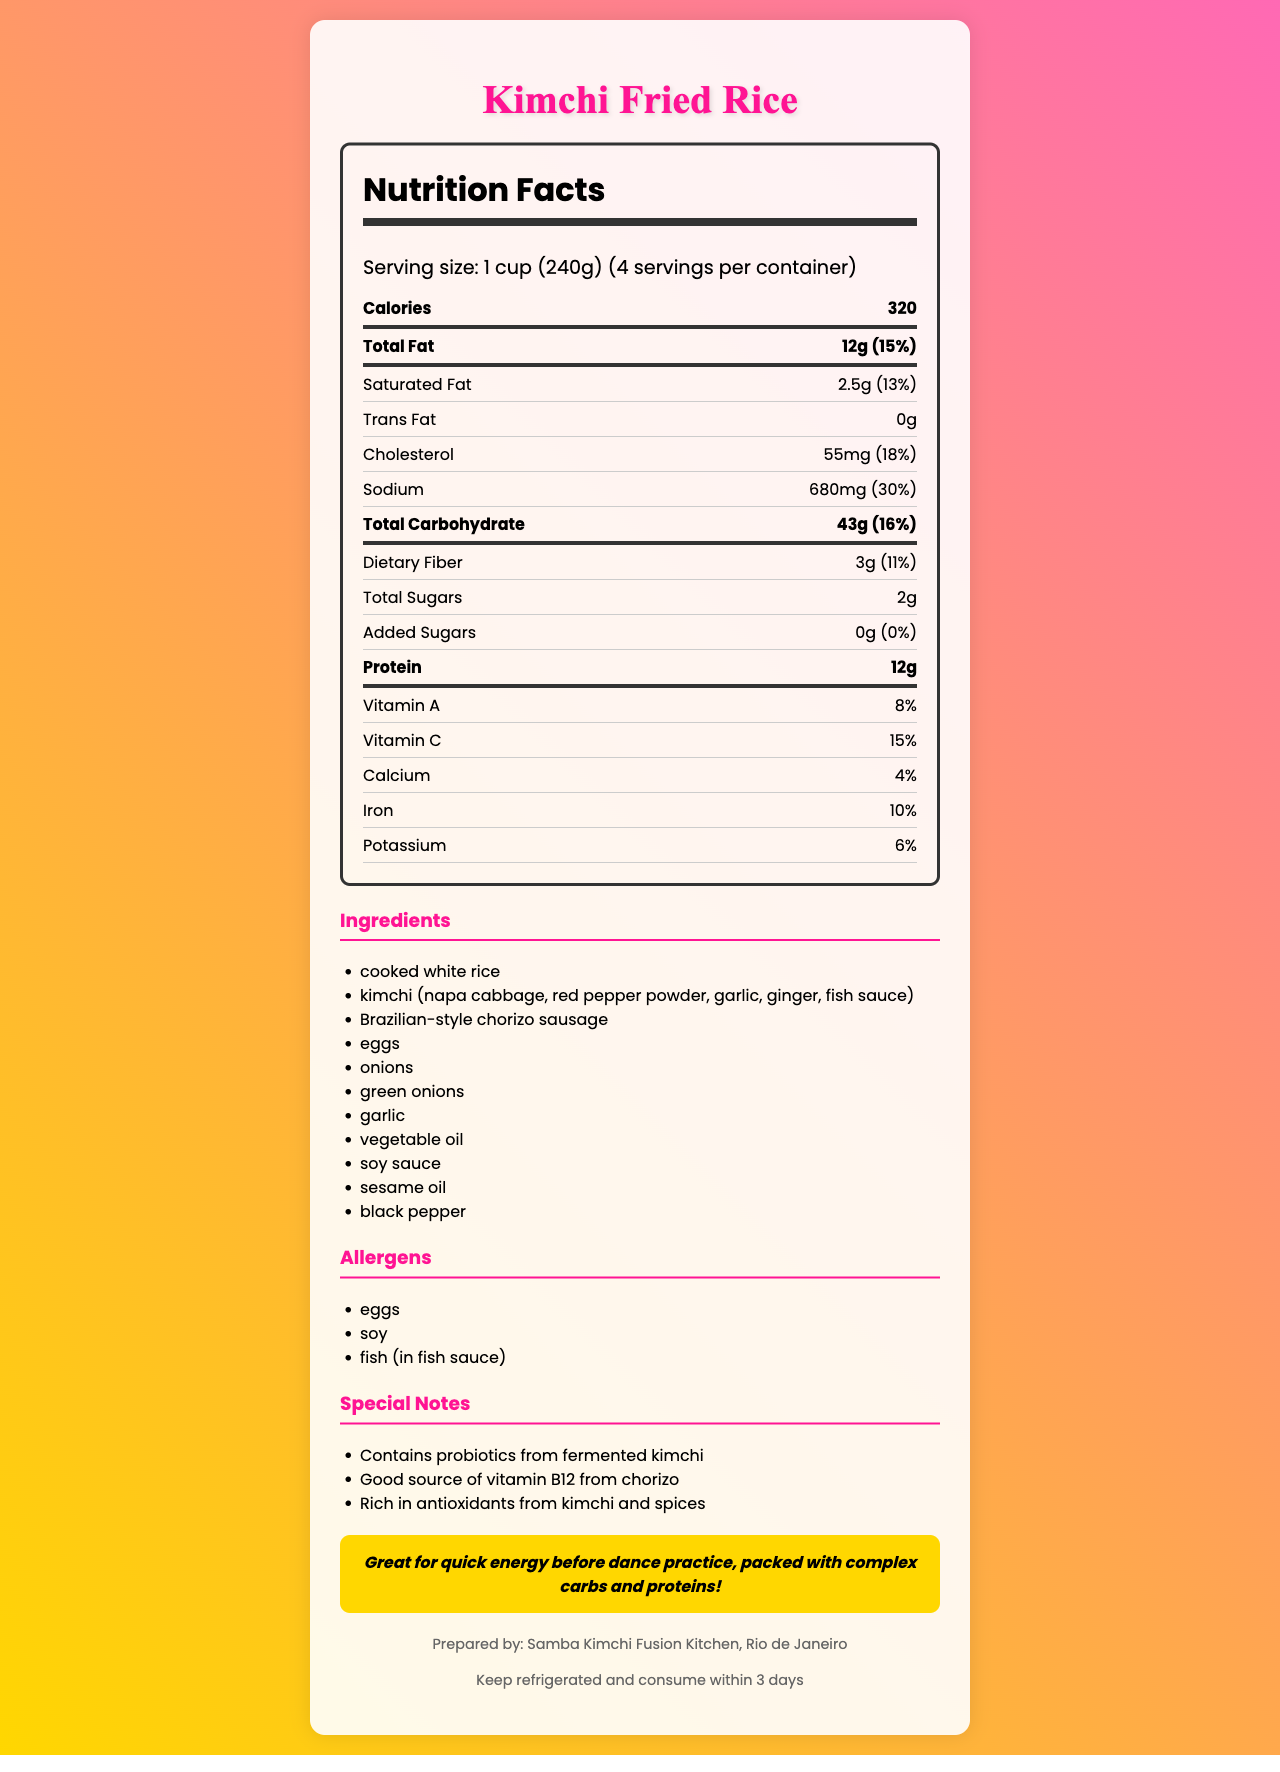What is the serving size of kimchi fried rice? The document specifies the serving size at the top.
Answer: 1 cup (240g) How many servings are in the container? The document lists "servings per container" as 4.
Answer: 4 How many calories are in one serving? The document states that there are 320 calories in each serving.
Answer: 320 What percentage of daily value is the sodium content per serving? The document shows that the sodium content per serving is 680mg, which is 30% of the daily value.
Answer: 30% How much protein does one serving of kimchi fried rice provide? The document lists the protein content as 12g per serving.
Answer: 12g What is the total carbohydrate content per serving? A. 43g B. 50g C. 37g D. 45g According to the document, the total carbohydrate content per serving is 43g.
Answer: A Which of the following allergens are present in the kimchi fried rice? I. Soy II. Eggs III. Milk IV. Fish (in fish sauce) The document lists soy, eggs, and fish (in fish sauce) as allergens.
Answer: I, II, and IV Does the kimchi fried rice contain any trans fat? The document specifically mentions "trans fat: 0g."
Answer: No Is there any added sugar in this food? The document shows 0g of added sugars per serving.
Answer: No What are the special notes mentioned for the kimchi fried rice? The document has a section for special notes listing these three points.
Answer: Contains probiotics from fermented kimchi, Good source of vitamin B12 from chorizo, Rich in antioxidants from kimchi and spices Who prepared the kimchi fried rice? The document mentions that it is prepared by Samba Kimchi Fusion Kitchen in Rio de Janeiro.
Answer: Samba Kimchi Fusion Kitchen, Rio de Janeiro Summarize the main nutritional benefits of kimchi fried rice. The document outlines these points in the nutritional breakdown and special notes sections.
Answer: The kimchi fried rice is a nutrient-dense food offering a balance of complex carbohydrates, proteins, probiotics, and vitamins. It contains 320 calories per serving, 12g of protein, and provides significant daily values of sodium, dietary fiber, and essential vitamins like Vitamin C and Vitamin A. It's also noted for its probiotics from kimchi and antioxidants from the spices. Does the kimchi fried rice contain calcium? The document shows that each serving contains 4% of the daily value for calcium.
Answer: Yes How many grams of dietary fiber are in one serving? The document lists 3g of dietary fiber per serving.
Answer: 3g What are the storage instructions for this dish? According to the document's storage instructions section.
Answer: Keep refrigerated and consume within 3 days Does this document provide the exact recipe for kimchi fried rice? The document lists ingredients but does not provide specific amounts or cooking instructions for making kimchi fried rice.
Answer: Cannot be determined 